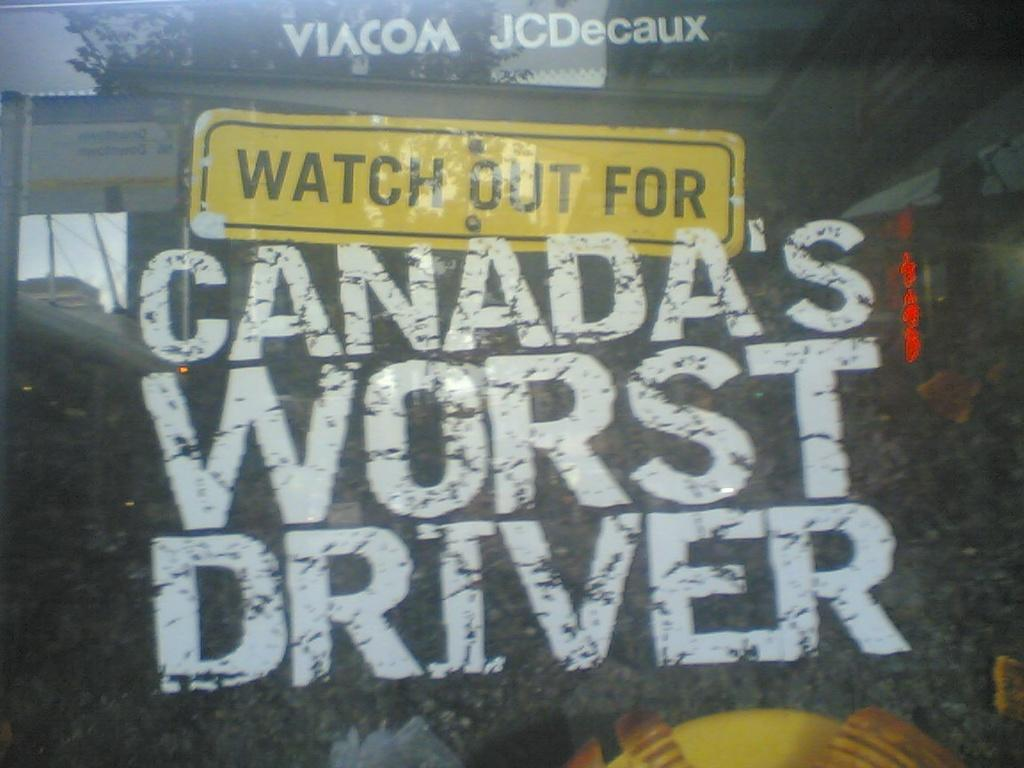What type of transparent material is present in the image? There is a glass window in the image. What is attached to the glass window? There is a poster on the window. What type of humor can be seen in the eyes of the person in the image? There is no person present in the image, and therefore no eyes or humor to observe. 